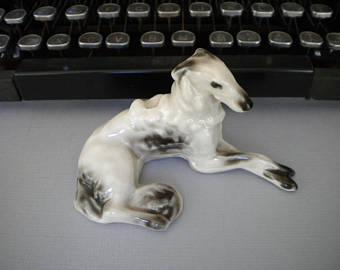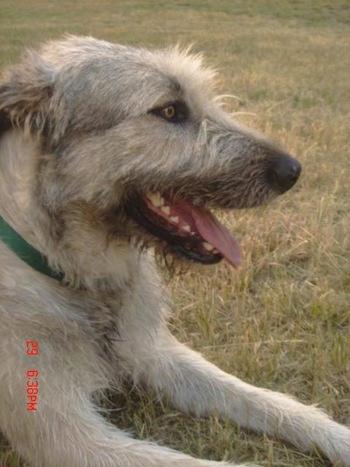The first image is the image on the left, the second image is the image on the right. Examine the images to the left and right. Is the description "The left and right image contains the same number of dogs with their bodies facing right." accurate? Answer yes or no. Yes. The first image is the image on the left, the second image is the image on the right. Assess this claim about the two images: "Two dogs are laying down.". Correct or not? Answer yes or no. Yes. 